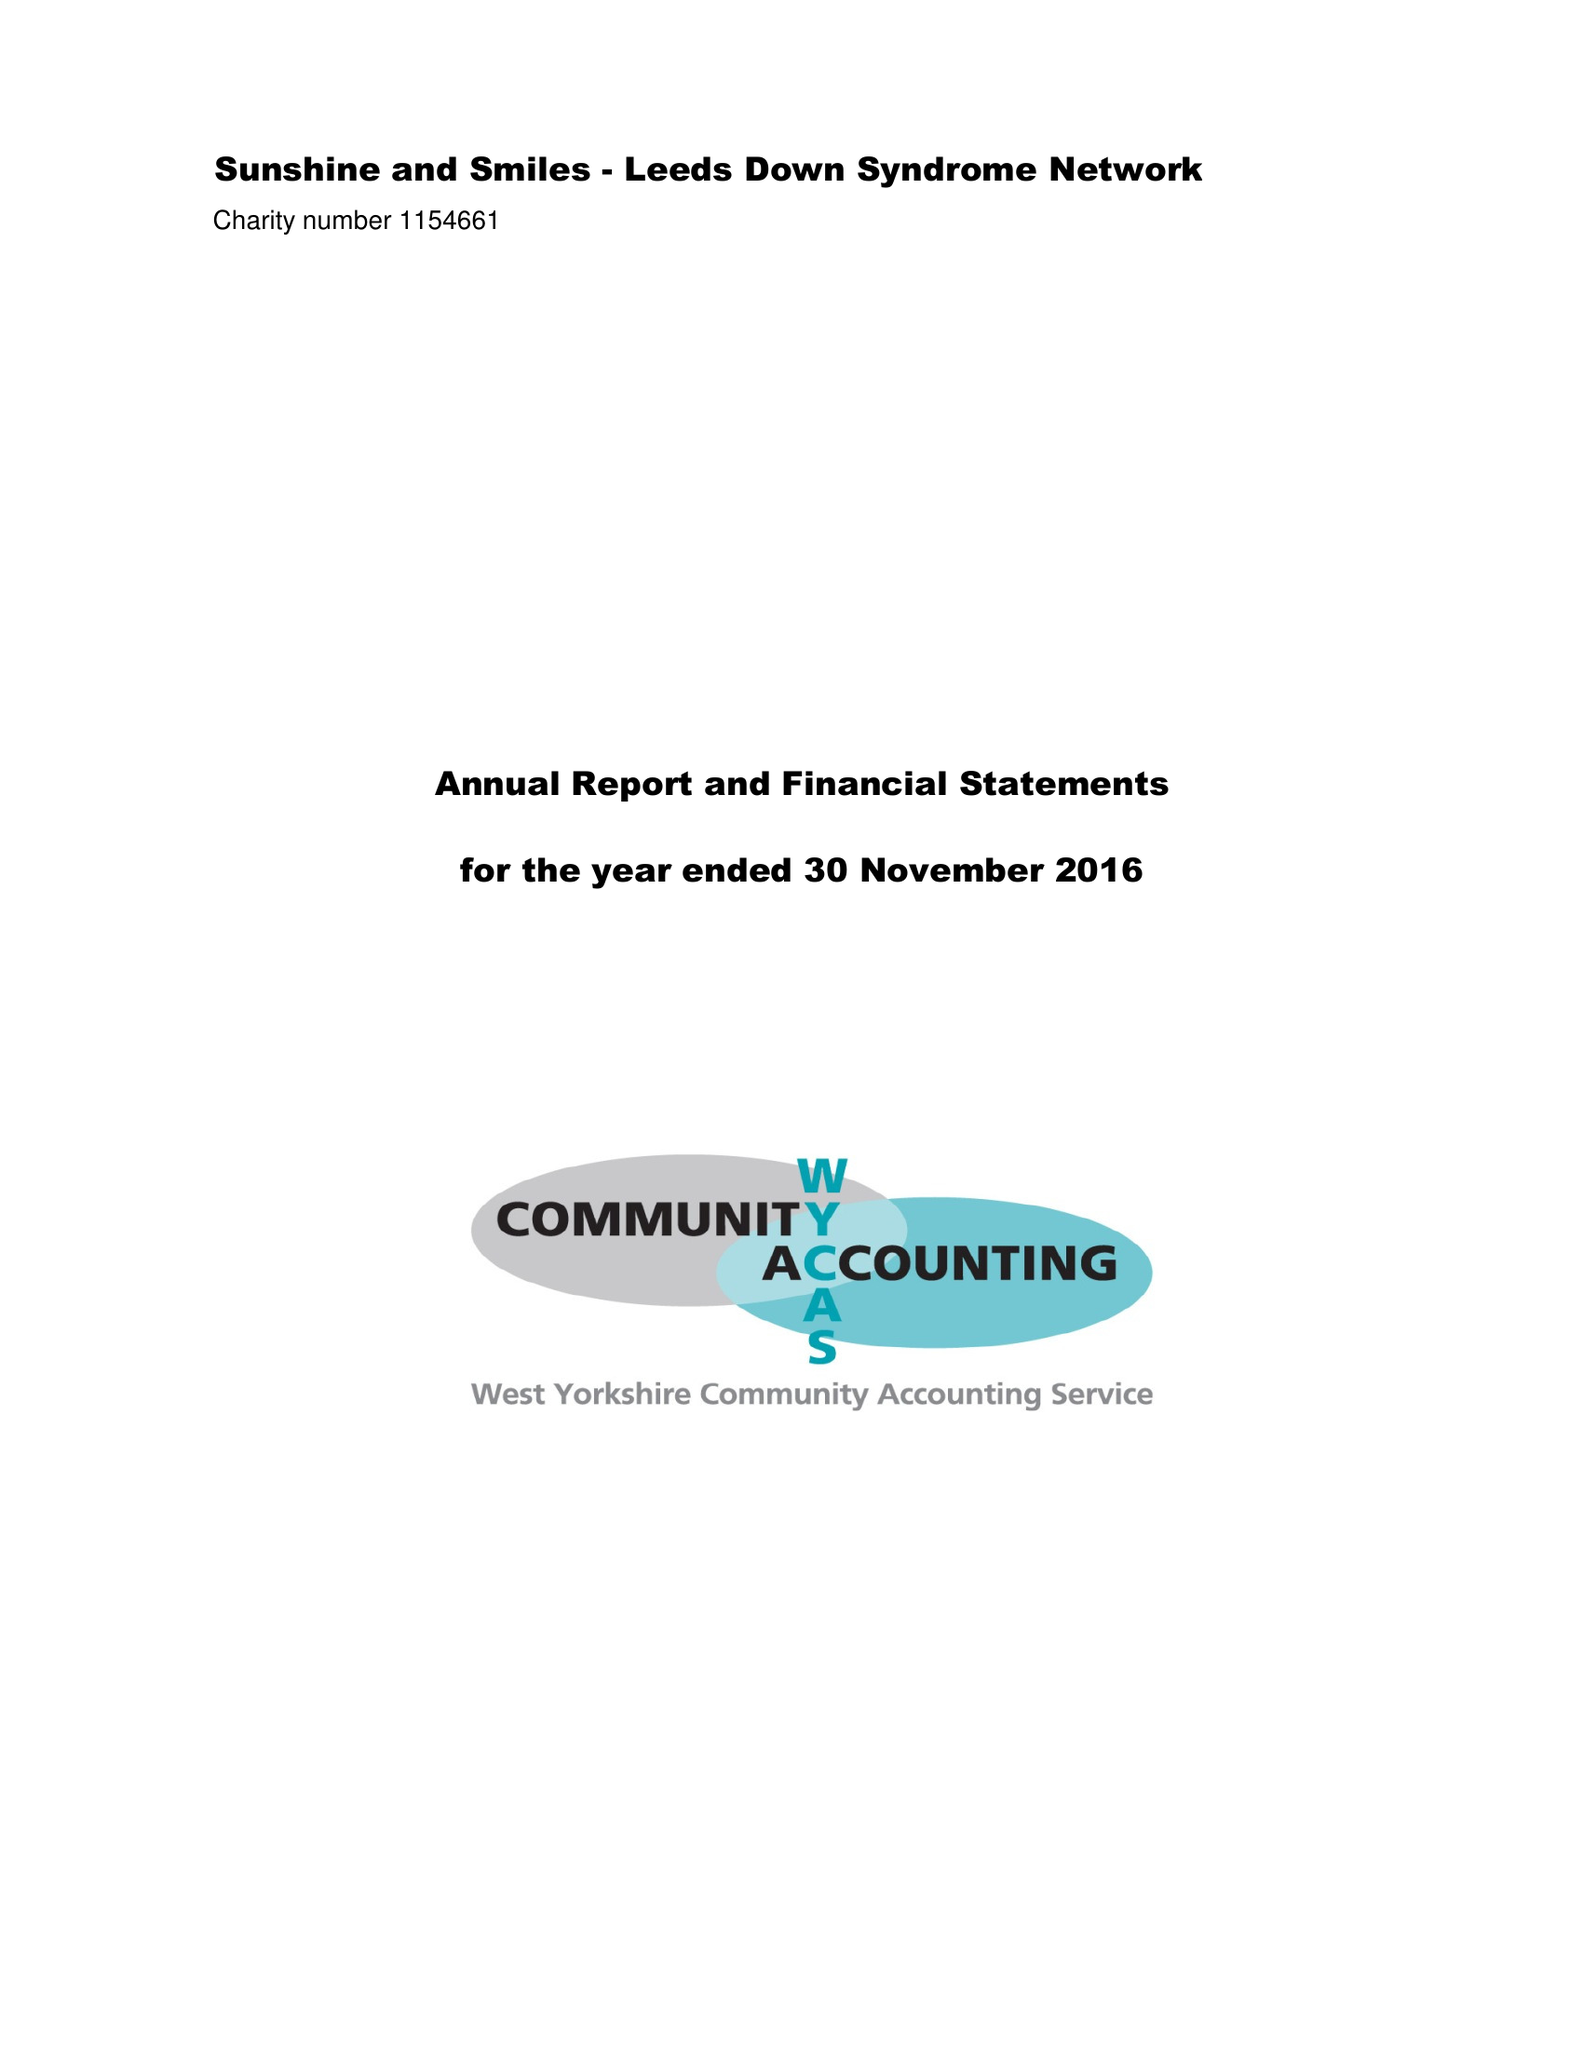What is the value for the report_date?
Answer the question using a single word or phrase. 2016-11-30 